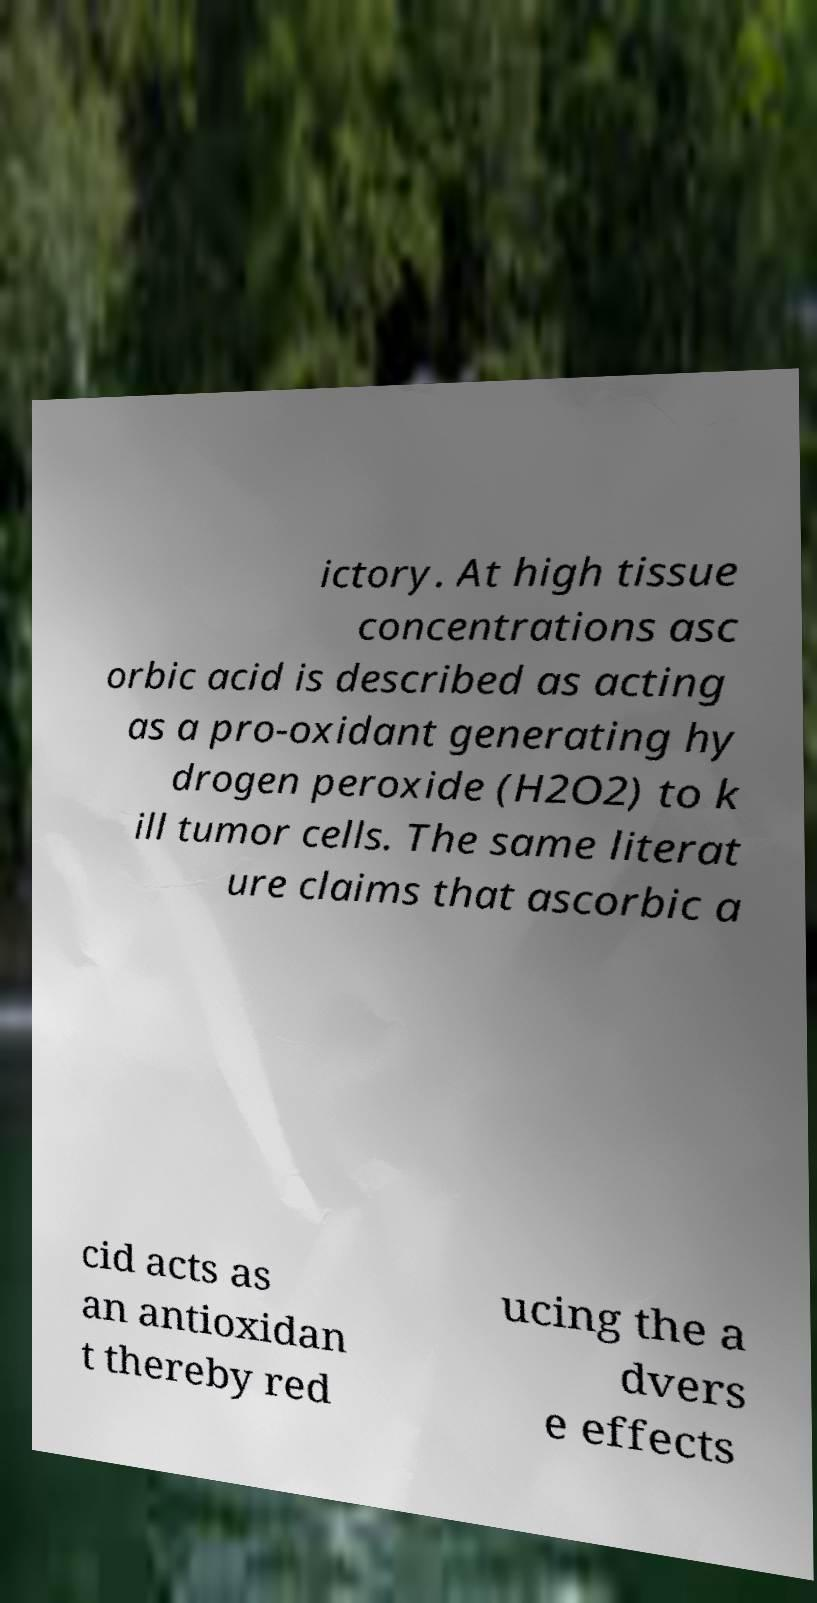Could you assist in decoding the text presented in this image and type it out clearly? ictory. At high tissue concentrations asc orbic acid is described as acting as a pro-oxidant generating hy drogen peroxide (H2O2) to k ill tumor cells. The same literat ure claims that ascorbic a cid acts as an antioxidan t thereby red ucing the a dvers e effects 